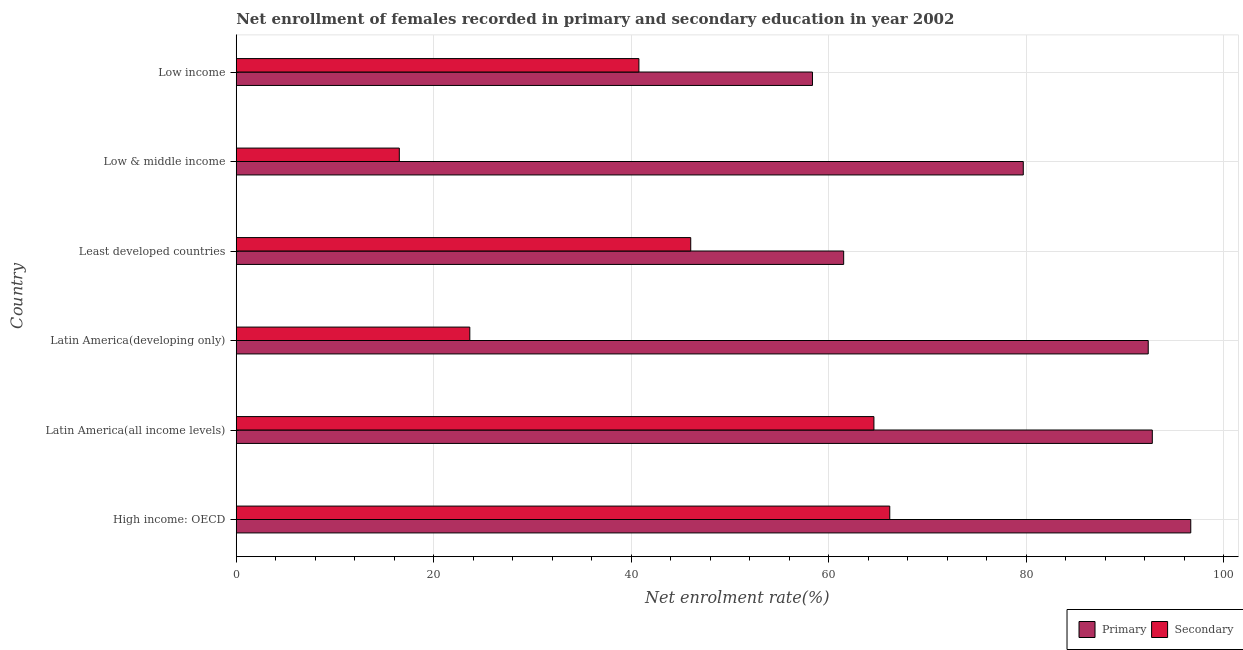How many different coloured bars are there?
Make the answer very short. 2. Are the number of bars per tick equal to the number of legend labels?
Keep it short and to the point. Yes. How many bars are there on the 1st tick from the top?
Provide a short and direct response. 2. How many bars are there on the 6th tick from the bottom?
Offer a very short reply. 2. What is the label of the 4th group of bars from the top?
Provide a short and direct response. Latin America(developing only). What is the enrollment rate in secondary education in Latin America(developing only)?
Ensure brevity in your answer.  23.66. Across all countries, what is the maximum enrollment rate in secondary education?
Keep it short and to the point. 66.2. Across all countries, what is the minimum enrollment rate in secondary education?
Provide a succinct answer. 16.52. In which country was the enrollment rate in primary education maximum?
Provide a succinct answer. High income: OECD. What is the total enrollment rate in primary education in the graph?
Provide a succinct answer. 481.46. What is the difference between the enrollment rate in secondary education in High income: OECD and that in Low income?
Give a very brief answer. 25.41. What is the difference between the enrollment rate in secondary education in Latin America(developing only) and the enrollment rate in primary education in Low income?
Your response must be concise. -34.71. What is the average enrollment rate in secondary education per country?
Provide a succinct answer. 42.96. What is the difference between the enrollment rate in secondary education and enrollment rate in primary education in Low & middle income?
Keep it short and to the point. -63.2. What is the ratio of the enrollment rate in primary education in Least developed countries to that in Low & middle income?
Give a very brief answer. 0.77. Is the enrollment rate in primary education in Latin America(developing only) less than that in Low & middle income?
Your response must be concise. No. What is the difference between the highest and the second highest enrollment rate in primary education?
Offer a very short reply. 3.9. What is the difference between the highest and the lowest enrollment rate in primary education?
Offer a terse response. 38.32. What does the 2nd bar from the top in Low income represents?
Your answer should be compact. Primary. What does the 1st bar from the bottom in Low & middle income represents?
Offer a very short reply. Primary. Are all the bars in the graph horizontal?
Your answer should be very brief. Yes. How many countries are there in the graph?
Keep it short and to the point. 6. What is the difference between two consecutive major ticks on the X-axis?
Your response must be concise. 20. Does the graph contain any zero values?
Offer a terse response. No. What is the title of the graph?
Offer a very short reply. Net enrollment of females recorded in primary and secondary education in year 2002. What is the label or title of the X-axis?
Offer a very short reply. Net enrolment rate(%). What is the label or title of the Y-axis?
Ensure brevity in your answer.  Country. What is the Net enrolment rate(%) of Primary in High income: OECD?
Offer a very short reply. 96.69. What is the Net enrolment rate(%) of Secondary in High income: OECD?
Your answer should be compact. 66.2. What is the Net enrolment rate(%) in Primary in Latin America(all income levels)?
Provide a succinct answer. 92.79. What is the Net enrolment rate(%) of Secondary in Latin America(all income levels)?
Your answer should be very brief. 64.59. What is the Net enrolment rate(%) of Primary in Latin America(developing only)?
Offer a terse response. 92.38. What is the Net enrolment rate(%) in Secondary in Latin America(developing only)?
Make the answer very short. 23.66. What is the Net enrolment rate(%) in Primary in Least developed countries?
Make the answer very short. 61.53. What is the Net enrolment rate(%) of Secondary in Least developed countries?
Your answer should be compact. 46.04. What is the Net enrolment rate(%) in Primary in Low & middle income?
Offer a very short reply. 79.72. What is the Net enrolment rate(%) of Secondary in Low & middle income?
Your answer should be very brief. 16.52. What is the Net enrolment rate(%) of Primary in Low income?
Offer a very short reply. 58.37. What is the Net enrolment rate(%) of Secondary in Low income?
Keep it short and to the point. 40.79. Across all countries, what is the maximum Net enrolment rate(%) in Primary?
Keep it short and to the point. 96.69. Across all countries, what is the maximum Net enrolment rate(%) in Secondary?
Keep it short and to the point. 66.2. Across all countries, what is the minimum Net enrolment rate(%) of Primary?
Your response must be concise. 58.37. Across all countries, what is the minimum Net enrolment rate(%) in Secondary?
Offer a terse response. 16.52. What is the total Net enrolment rate(%) in Primary in the graph?
Make the answer very short. 481.46. What is the total Net enrolment rate(%) of Secondary in the graph?
Your answer should be compact. 257.78. What is the difference between the Net enrolment rate(%) of Primary in High income: OECD and that in Latin America(all income levels)?
Provide a succinct answer. 3.89. What is the difference between the Net enrolment rate(%) of Secondary in High income: OECD and that in Latin America(all income levels)?
Offer a terse response. 1.61. What is the difference between the Net enrolment rate(%) in Primary in High income: OECD and that in Latin America(developing only)?
Provide a short and direct response. 4.31. What is the difference between the Net enrolment rate(%) of Secondary in High income: OECD and that in Latin America(developing only)?
Make the answer very short. 42.54. What is the difference between the Net enrolment rate(%) of Primary in High income: OECD and that in Least developed countries?
Provide a short and direct response. 35.16. What is the difference between the Net enrolment rate(%) in Secondary in High income: OECD and that in Least developed countries?
Your response must be concise. 20.16. What is the difference between the Net enrolment rate(%) in Primary in High income: OECD and that in Low & middle income?
Provide a short and direct response. 16.97. What is the difference between the Net enrolment rate(%) of Secondary in High income: OECD and that in Low & middle income?
Ensure brevity in your answer.  49.68. What is the difference between the Net enrolment rate(%) of Primary in High income: OECD and that in Low income?
Your answer should be very brief. 38.32. What is the difference between the Net enrolment rate(%) of Secondary in High income: OECD and that in Low income?
Keep it short and to the point. 25.41. What is the difference between the Net enrolment rate(%) in Primary in Latin America(all income levels) and that in Latin America(developing only)?
Make the answer very short. 0.41. What is the difference between the Net enrolment rate(%) of Secondary in Latin America(all income levels) and that in Latin America(developing only)?
Ensure brevity in your answer.  40.93. What is the difference between the Net enrolment rate(%) in Primary in Latin America(all income levels) and that in Least developed countries?
Make the answer very short. 31.26. What is the difference between the Net enrolment rate(%) of Secondary in Latin America(all income levels) and that in Least developed countries?
Give a very brief answer. 18.56. What is the difference between the Net enrolment rate(%) of Primary in Latin America(all income levels) and that in Low & middle income?
Provide a short and direct response. 13.07. What is the difference between the Net enrolment rate(%) in Secondary in Latin America(all income levels) and that in Low & middle income?
Provide a succinct answer. 48.07. What is the difference between the Net enrolment rate(%) of Primary in Latin America(all income levels) and that in Low income?
Offer a terse response. 34.42. What is the difference between the Net enrolment rate(%) of Secondary in Latin America(all income levels) and that in Low income?
Give a very brief answer. 23.81. What is the difference between the Net enrolment rate(%) of Primary in Latin America(developing only) and that in Least developed countries?
Your response must be concise. 30.85. What is the difference between the Net enrolment rate(%) in Secondary in Latin America(developing only) and that in Least developed countries?
Offer a terse response. -22.38. What is the difference between the Net enrolment rate(%) of Primary in Latin America(developing only) and that in Low & middle income?
Give a very brief answer. 12.66. What is the difference between the Net enrolment rate(%) of Secondary in Latin America(developing only) and that in Low & middle income?
Keep it short and to the point. 7.14. What is the difference between the Net enrolment rate(%) in Primary in Latin America(developing only) and that in Low income?
Give a very brief answer. 34.01. What is the difference between the Net enrolment rate(%) in Secondary in Latin America(developing only) and that in Low income?
Your answer should be compact. -17.13. What is the difference between the Net enrolment rate(%) in Primary in Least developed countries and that in Low & middle income?
Provide a succinct answer. -18.19. What is the difference between the Net enrolment rate(%) in Secondary in Least developed countries and that in Low & middle income?
Your answer should be compact. 29.52. What is the difference between the Net enrolment rate(%) of Primary in Least developed countries and that in Low income?
Your response must be concise. 3.16. What is the difference between the Net enrolment rate(%) of Secondary in Least developed countries and that in Low income?
Make the answer very short. 5.25. What is the difference between the Net enrolment rate(%) of Primary in Low & middle income and that in Low income?
Ensure brevity in your answer.  21.35. What is the difference between the Net enrolment rate(%) in Secondary in Low & middle income and that in Low income?
Your response must be concise. -24.27. What is the difference between the Net enrolment rate(%) of Primary in High income: OECD and the Net enrolment rate(%) of Secondary in Latin America(all income levels)?
Offer a terse response. 32.09. What is the difference between the Net enrolment rate(%) of Primary in High income: OECD and the Net enrolment rate(%) of Secondary in Latin America(developing only)?
Your answer should be compact. 73.03. What is the difference between the Net enrolment rate(%) in Primary in High income: OECD and the Net enrolment rate(%) in Secondary in Least developed countries?
Provide a succinct answer. 50.65. What is the difference between the Net enrolment rate(%) in Primary in High income: OECD and the Net enrolment rate(%) in Secondary in Low & middle income?
Your answer should be compact. 80.17. What is the difference between the Net enrolment rate(%) in Primary in High income: OECD and the Net enrolment rate(%) in Secondary in Low income?
Your response must be concise. 55.9. What is the difference between the Net enrolment rate(%) of Primary in Latin America(all income levels) and the Net enrolment rate(%) of Secondary in Latin America(developing only)?
Make the answer very short. 69.13. What is the difference between the Net enrolment rate(%) in Primary in Latin America(all income levels) and the Net enrolment rate(%) in Secondary in Least developed countries?
Provide a succinct answer. 46.75. What is the difference between the Net enrolment rate(%) in Primary in Latin America(all income levels) and the Net enrolment rate(%) in Secondary in Low & middle income?
Offer a very short reply. 76.27. What is the difference between the Net enrolment rate(%) in Primary in Latin America(all income levels) and the Net enrolment rate(%) in Secondary in Low income?
Ensure brevity in your answer.  52. What is the difference between the Net enrolment rate(%) of Primary in Latin America(developing only) and the Net enrolment rate(%) of Secondary in Least developed countries?
Your answer should be very brief. 46.34. What is the difference between the Net enrolment rate(%) in Primary in Latin America(developing only) and the Net enrolment rate(%) in Secondary in Low & middle income?
Keep it short and to the point. 75.86. What is the difference between the Net enrolment rate(%) of Primary in Latin America(developing only) and the Net enrolment rate(%) of Secondary in Low income?
Provide a succinct answer. 51.59. What is the difference between the Net enrolment rate(%) in Primary in Least developed countries and the Net enrolment rate(%) in Secondary in Low & middle income?
Make the answer very short. 45.01. What is the difference between the Net enrolment rate(%) of Primary in Least developed countries and the Net enrolment rate(%) of Secondary in Low income?
Keep it short and to the point. 20.74. What is the difference between the Net enrolment rate(%) in Primary in Low & middle income and the Net enrolment rate(%) in Secondary in Low income?
Offer a terse response. 38.93. What is the average Net enrolment rate(%) of Primary per country?
Your response must be concise. 80.24. What is the average Net enrolment rate(%) in Secondary per country?
Provide a short and direct response. 42.96. What is the difference between the Net enrolment rate(%) of Primary and Net enrolment rate(%) of Secondary in High income: OECD?
Provide a succinct answer. 30.49. What is the difference between the Net enrolment rate(%) of Primary and Net enrolment rate(%) of Secondary in Latin America(all income levels)?
Provide a short and direct response. 28.2. What is the difference between the Net enrolment rate(%) of Primary and Net enrolment rate(%) of Secondary in Latin America(developing only)?
Provide a short and direct response. 68.72. What is the difference between the Net enrolment rate(%) of Primary and Net enrolment rate(%) of Secondary in Least developed countries?
Provide a short and direct response. 15.49. What is the difference between the Net enrolment rate(%) in Primary and Net enrolment rate(%) in Secondary in Low & middle income?
Give a very brief answer. 63.2. What is the difference between the Net enrolment rate(%) of Primary and Net enrolment rate(%) of Secondary in Low income?
Give a very brief answer. 17.58. What is the ratio of the Net enrolment rate(%) of Primary in High income: OECD to that in Latin America(all income levels)?
Ensure brevity in your answer.  1.04. What is the ratio of the Net enrolment rate(%) in Secondary in High income: OECD to that in Latin America(all income levels)?
Your answer should be very brief. 1.02. What is the ratio of the Net enrolment rate(%) in Primary in High income: OECD to that in Latin America(developing only)?
Ensure brevity in your answer.  1.05. What is the ratio of the Net enrolment rate(%) in Secondary in High income: OECD to that in Latin America(developing only)?
Your answer should be compact. 2.8. What is the ratio of the Net enrolment rate(%) of Primary in High income: OECD to that in Least developed countries?
Offer a terse response. 1.57. What is the ratio of the Net enrolment rate(%) in Secondary in High income: OECD to that in Least developed countries?
Offer a very short reply. 1.44. What is the ratio of the Net enrolment rate(%) in Primary in High income: OECD to that in Low & middle income?
Ensure brevity in your answer.  1.21. What is the ratio of the Net enrolment rate(%) in Secondary in High income: OECD to that in Low & middle income?
Make the answer very short. 4.01. What is the ratio of the Net enrolment rate(%) of Primary in High income: OECD to that in Low income?
Your answer should be very brief. 1.66. What is the ratio of the Net enrolment rate(%) of Secondary in High income: OECD to that in Low income?
Ensure brevity in your answer.  1.62. What is the ratio of the Net enrolment rate(%) in Secondary in Latin America(all income levels) to that in Latin America(developing only)?
Your answer should be compact. 2.73. What is the ratio of the Net enrolment rate(%) of Primary in Latin America(all income levels) to that in Least developed countries?
Make the answer very short. 1.51. What is the ratio of the Net enrolment rate(%) of Secondary in Latin America(all income levels) to that in Least developed countries?
Keep it short and to the point. 1.4. What is the ratio of the Net enrolment rate(%) of Primary in Latin America(all income levels) to that in Low & middle income?
Provide a short and direct response. 1.16. What is the ratio of the Net enrolment rate(%) in Secondary in Latin America(all income levels) to that in Low & middle income?
Your answer should be compact. 3.91. What is the ratio of the Net enrolment rate(%) in Primary in Latin America(all income levels) to that in Low income?
Keep it short and to the point. 1.59. What is the ratio of the Net enrolment rate(%) of Secondary in Latin America(all income levels) to that in Low income?
Ensure brevity in your answer.  1.58. What is the ratio of the Net enrolment rate(%) in Primary in Latin America(developing only) to that in Least developed countries?
Give a very brief answer. 1.5. What is the ratio of the Net enrolment rate(%) in Secondary in Latin America(developing only) to that in Least developed countries?
Offer a very short reply. 0.51. What is the ratio of the Net enrolment rate(%) of Primary in Latin America(developing only) to that in Low & middle income?
Keep it short and to the point. 1.16. What is the ratio of the Net enrolment rate(%) in Secondary in Latin America(developing only) to that in Low & middle income?
Your answer should be very brief. 1.43. What is the ratio of the Net enrolment rate(%) of Primary in Latin America(developing only) to that in Low income?
Your response must be concise. 1.58. What is the ratio of the Net enrolment rate(%) in Secondary in Latin America(developing only) to that in Low income?
Keep it short and to the point. 0.58. What is the ratio of the Net enrolment rate(%) of Primary in Least developed countries to that in Low & middle income?
Ensure brevity in your answer.  0.77. What is the ratio of the Net enrolment rate(%) of Secondary in Least developed countries to that in Low & middle income?
Your response must be concise. 2.79. What is the ratio of the Net enrolment rate(%) of Primary in Least developed countries to that in Low income?
Make the answer very short. 1.05. What is the ratio of the Net enrolment rate(%) of Secondary in Least developed countries to that in Low income?
Provide a succinct answer. 1.13. What is the ratio of the Net enrolment rate(%) of Primary in Low & middle income to that in Low income?
Ensure brevity in your answer.  1.37. What is the ratio of the Net enrolment rate(%) of Secondary in Low & middle income to that in Low income?
Provide a short and direct response. 0.41. What is the difference between the highest and the second highest Net enrolment rate(%) of Primary?
Make the answer very short. 3.89. What is the difference between the highest and the second highest Net enrolment rate(%) in Secondary?
Provide a succinct answer. 1.61. What is the difference between the highest and the lowest Net enrolment rate(%) in Primary?
Ensure brevity in your answer.  38.32. What is the difference between the highest and the lowest Net enrolment rate(%) in Secondary?
Provide a short and direct response. 49.68. 